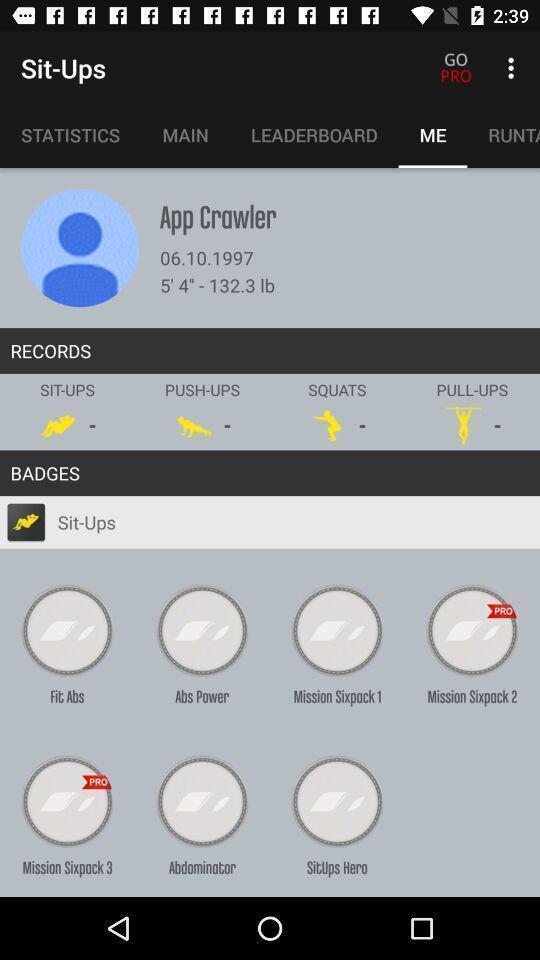What can you discern from this picture? Various options displayed for workouts. 